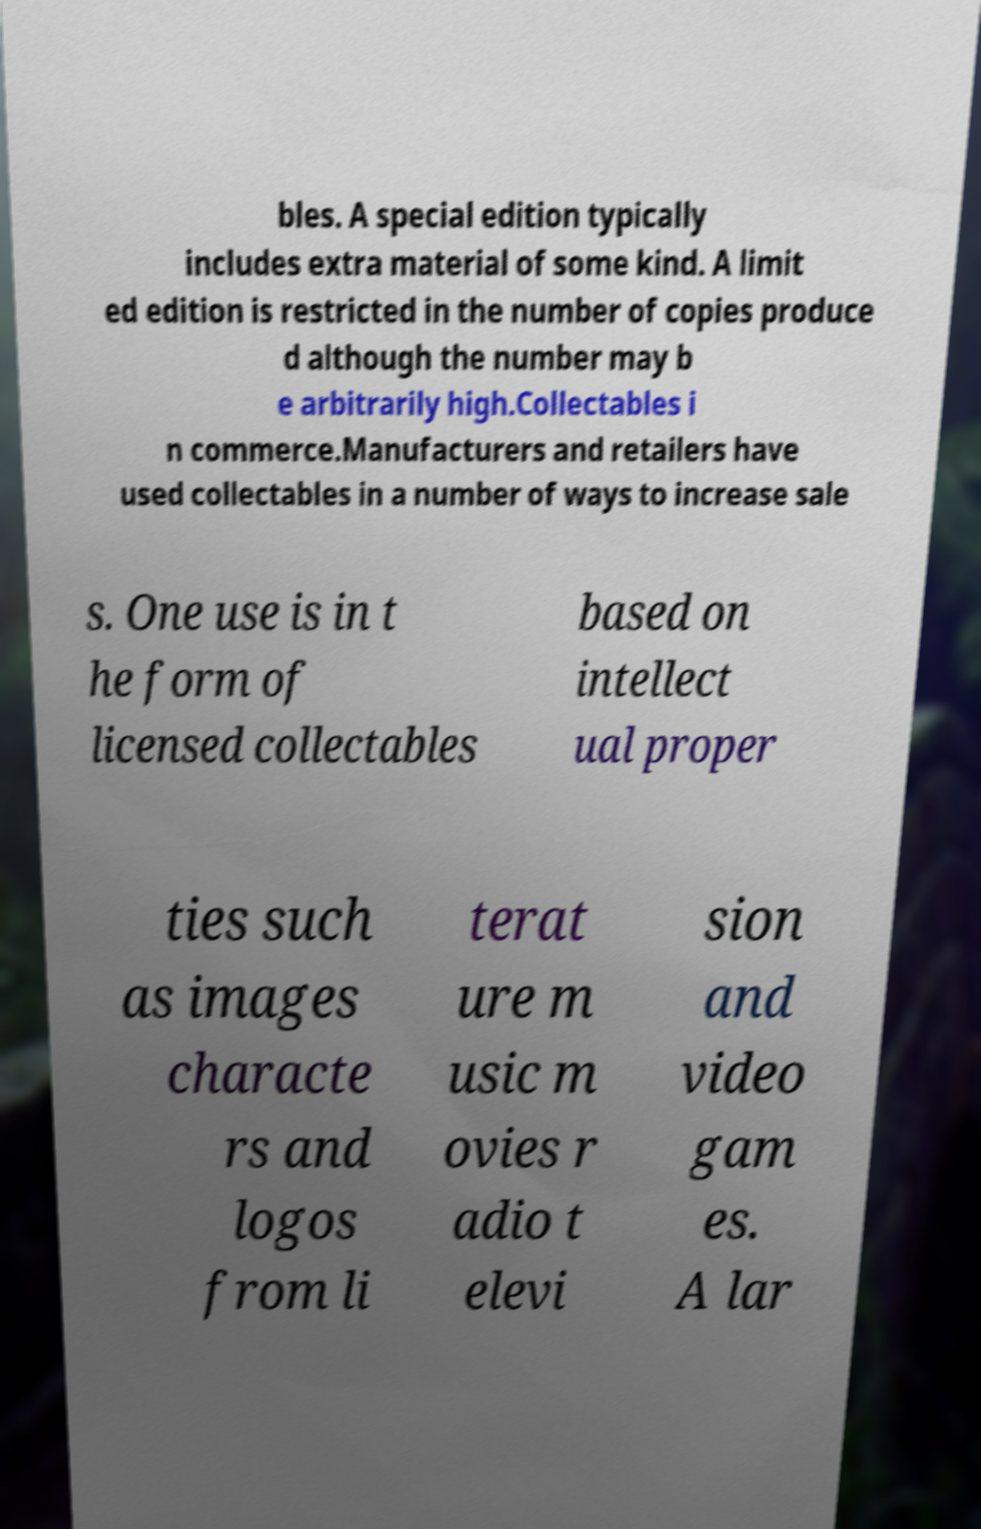I need the written content from this picture converted into text. Can you do that? bles. A special edition typically includes extra material of some kind. A limit ed edition is restricted in the number of copies produce d although the number may b e arbitrarily high.Collectables i n commerce.Manufacturers and retailers have used collectables in a number of ways to increase sale s. One use is in t he form of licensed collectables based on intellect ual proper ties such as images characte rs and logos from li terat ure m usic m ovies r adio t elevi sion and video gam es. A lar 